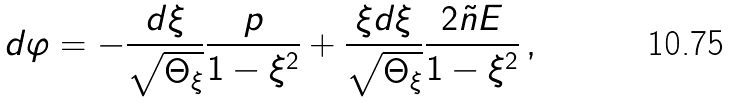<formula> <loc_0><loc_0><loc_500><loc_500>d \varphi = - \frac { d \xi } { \sqrt { \Theta _ { \xi } } } \frac { \L p } { 1 - \xi ^ { 2 } } + \frac { \xi d \xi } { \sqrt { \Theta _ { \xi } } } \frac { 2 \tilde { n } { E } } { 1 - \xi ^ { 2 } } \, ,</formula> 